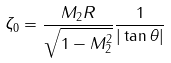<formula> <loc_0><loc_0><loc_500><loc_500>\zeta _ { 0 } = \frac { M _ { 2 } R } { \sqrt { 1 - M _ { 2 } ^ { 2 } } } \frac { 1 } { | \tan \theta | } \,</formula> 